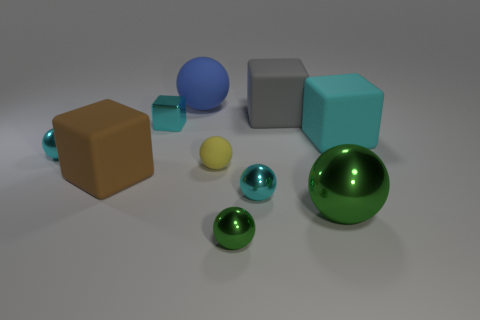How many cyan rubber cylinders are the same size as the cyan rubber cube?
Offer a terse response. 0. Does the big gray block have the same material as the large sphere left of the large green ball?
Your answer should be compact. Yes. Are there fewer tiny green things than small gray objects?
Keep it short and to the point. No. Is there any other thing of the same color as the large matte sphere?
Make the answer very short. No. There is a tiny green thing that is made of the same material as the large green object; what is its shape?
Make the answer very short. Sphere. There is a cyan rubber cube that is to the right of the matte ball that is in front of the large cyan thing; how many tiny yellow rubber objects are behind it?
Your answer should be very brief. 0. There is a big thing that is both behind the large green sphere and on the right side of the gray object; what shape is it?
Make the answer very short. Cube. Are there fewer cyan objects that are right of the big green shiny sphere than small cyan metallic spheres?
Provide a short and direct response. Yes. What number of large objects are either cyan rubber blocks or metal blocks?
Your answer should be very brief. 1. How big is the yellow sphere?
Provide a succinct answer. Small. 